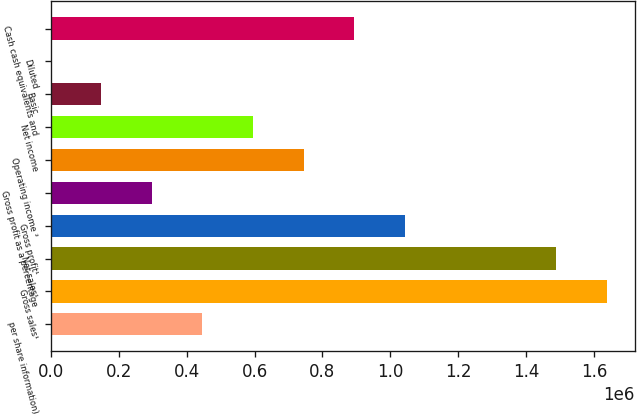<chart> <loc_0><loc_0><loc_500><loc_500><bar_chart><fcel>per share information)<fcel>Gross sales¹<fcel>Net sales¹<fcel>Gross profit¹<fcel>Gross profit as a percentage<fcel>Operating income ²<fcel>Net income<fcel>Basic<fcel>Diluted<fcel>Cash cash equivalents and<nl><fcel>446556<fcel>1.63737e+06<fcel>1.48852e+06<fcel>1.04196e+06<fcel>297704<fcel>744259<fcel>595407<fcel>148853<fcel>1.14<fcel>893110<nl></chart> 